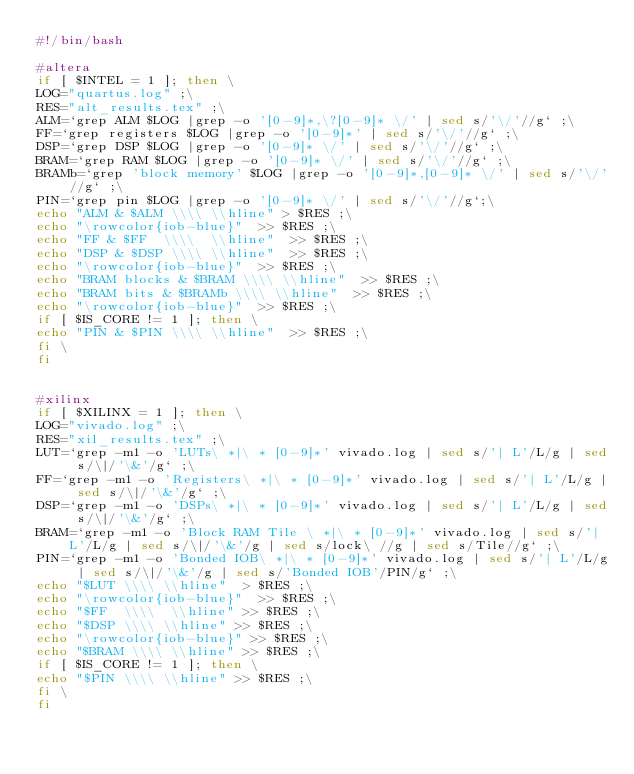<code> <loc_0><loc_0><loc_500><loc_500><_Bash_>#!/bin/bash

#altera
if [ $INTEL = 1 ]; then \
LOG="quartus.log" ;\
RES="alt_results.tex" ;\
ALM=`grep ALM $LOG |grep -o '[0-9]*,\?[0-9]* \/' | sed s/'\/'//g` ;\
FF=`grep registers $LOG |grep -o '[0-9]*' | sed s/'\/'//g` ;\
DSP=`grep DSP $LOG |grep -o '[0-9]* \/' | sed s/'\/'//g` ;\
BRAM=`grep RAM $LOG |grep -o '[0-9]* \/' | sed s/'\/'//g` ;\
BRAMb=`grep 'block memory' $LOG |grep -o '[0-9]*,[0-9]* \/' | sed s/'\/'//g` ;\
PIN=`grep pin $LOG |grep -o '[0-9]* \/' | sed s/'\/'//g`;\
echo "ALM & $ALM \\\\ \\hline" > $RES ;\
echo "\rowcolor{iob-blue}"  >> $RES ;\
echo "FF & $FF  \\\\  \\hline"  >> $RES ;\
echo "DSP & $DSP \\\\ \\hline"  >> $RES ;\
echo "\rowcolor{iob-blue}"  >> $RES ;\
echo "BRAM blocks & $BRAM \\\\ \\hline"  >> $RES ;\
echo "BRAM bits & $BRAMb \\\\ \\hline"  >> $RES ;\
echo "\rowcolor{iob-blue}"  >> $RES ;\
if [ $IS_CORE != 1 ]; then \
echo "PIN & $PIN \\\\ \\hline"  >> $RES ;\
fi \
fi


#xilinx
if [ $XILINX = 1 ]; then \
LOG="vivado.log" ;\
RES="xil_results.tex" ;\
LUT=`grep -m1 -o 'LUTs\ *|\ * [0-9]*' vivado.log | sed s/'| L'/L/g | sed s/\|/'\&'/g` ;\
FF=`grep -m1 -o 'Registers\ *|\ * [0-9]*' vivado.log | sed s/'| L'/L/g | sed s/\|/'\&'/g` ;\
DSP=`grep -m1 -o 'DSPs\ *|\ * [0-9]*' vivado.log | sed s/'| L'/L/g | sed s/\|/'\&'/g` ;\
BRAM=`grep -m1 -o 'Block RAM Tile \ *|\ * [0-9]*' vivado.log | sed s/'| L'/L/g | sed s/\|/'\&'/g | sed s/lock\ //g | sed s/Tile//g` ;\
PIN=`grep -m1 -o 'Bonded IOB\ *|\ * [0-9]*' vivado.log | sed s/'| L'/L/g | sed s/\|/'\&'/g | sed s/'Bonded IOB'/PIN/g` ;\
echo "$LUT \\\\ \\hline"  > $RES ;\
echo "\rowcolor{iob-blue}"  >> $RES ;\
echo "$FF  \\\\  \\hline" >> $RES ;\
echo "$DSP \\\\ \\hline" >> $RES ;\
echo "\rowcolor{iob-blue}" >> $RES ;\
echo "$BRAM \\\\ \\hline" >> $RES ;\
if [ $IS_CORE != 1 ]; then \
echo "$PIN \\\\ \\hline" >> $RES ;\
fi \
fi
</code> 